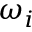Convert formula to latex. <formula><loc_0><loc_0><loc_500><loc_500>\omega _ { i }</formula> 